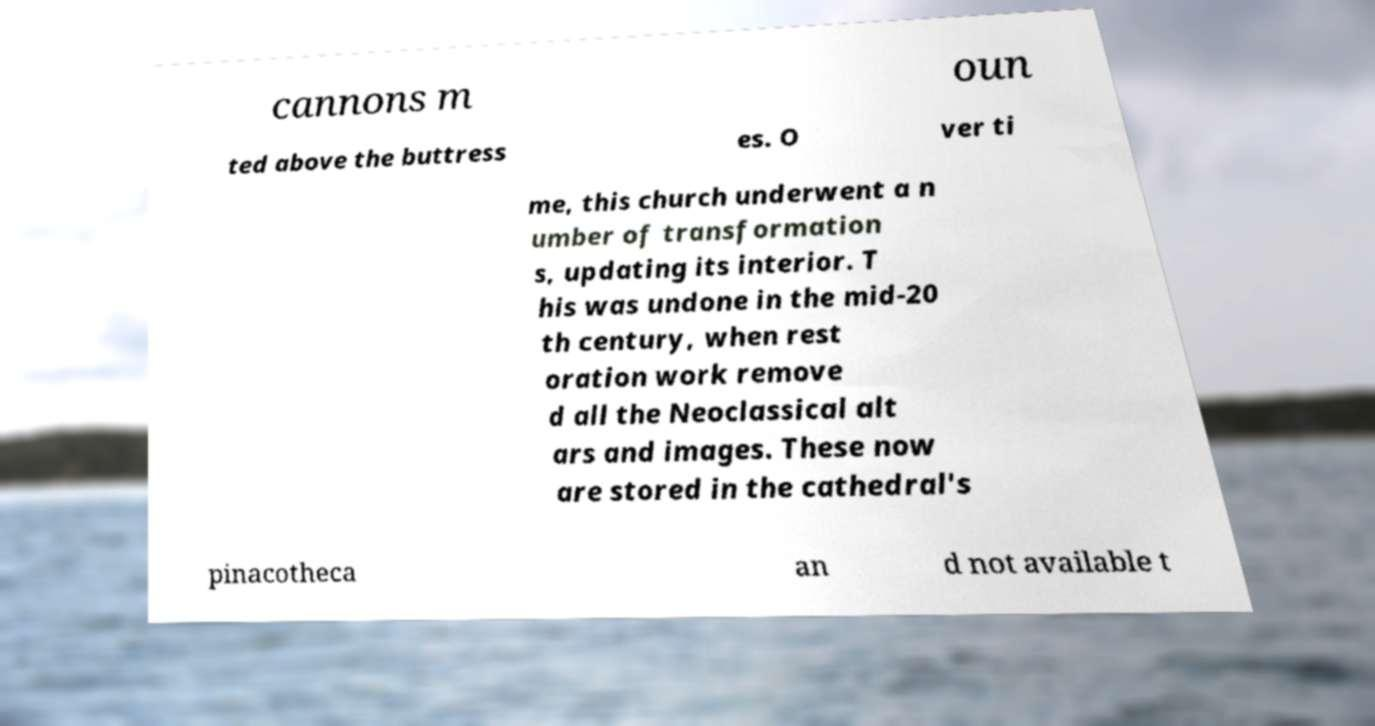I need the written content from this picture converted into text. Can you do that? cannons m oun ted above the buttress es. O ver ti me, this church underwent a n umber of transformation s, updating its interior. T his was undone in the mid-20 th century, when rest oration work remove d all the Neoclassical alt ars and images. These now are stored in the cathedral's pinacotheca an d not available t 